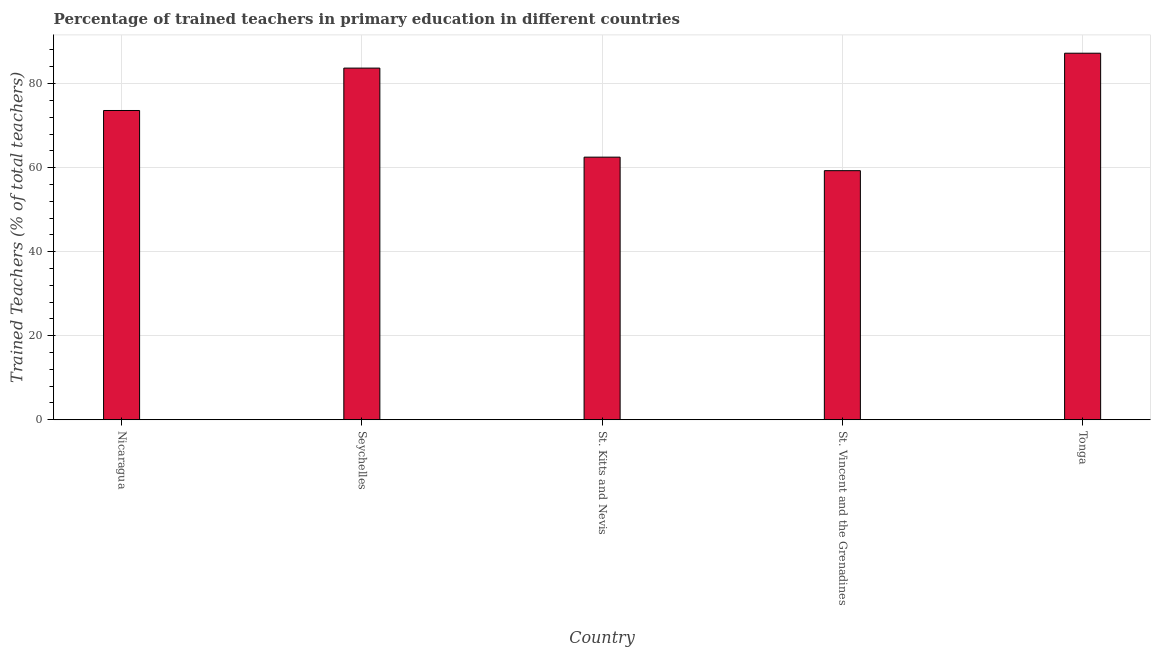What is the title of the graph?
Ensure brevity in your answer.  Percentage of trained teachers in primary education in different countries. What is the label or title of the X-axis?
Ensure brevity in your answer.  Country. What is the label or title of the Y-axis?
Keep it short and to the point. Trained Teachers (% of total teachers). What is the percentage of trained teachers in St. Kitts and Nevis?
Give a very brief answer. 62.5. Across all countries, what is the maximum percentage of trained teachers?
Offer a very short reply. 87.23. Across all countries, what is the minimum percentage of trained teachers?
Your answer should be very brief. 59.28. In which country was the percentage of trained teachers maximum?
Provide a short and direct response. Tonga. In which country was the percentage of trained teachers minimum?
Your answer should be compact. St. Vincent and the Grenadines. What is the sum of the percentage of trained teachers?
Your answer should be very brief. 366.31. What is the difference between the percentage of trained teachers in Seychelles and St. Kitts and Nevis?
Provide a succinct answer. 21.19. What is the average percentage of trained teachers per country?
Keep it short and to the point. 73.26. What is the median percentage of trained teachers?
Provide a succinct answer. 73.6. In how many countries, is the percentage of trained teachers greater than 72 %?
Give a very brief answer. 3. What is the ratio of the percentage of trained teachers in Seychelles to that in St. Kitts and Nevis?
Provide a short and direct response. 1.34. Is the percentage of trained teachers in Seychelles less than that in St. Vincent and the Grenadines?
Your response must be concise. No. Is the difference between the percentage of trained teachers in Nicaragua and St. Kitts and Nevis greater than the difference between any two countries?
Make the answer very short. No. What is the difference between the highest and the second highest percentage of trained teachers?
Your answer should be compact. 3.54. What is the difference between the highest and the lowest percentage of trained teachers?
Keep it short and to the point. 27.95. In how many countries, is the percentage of trained teachers greater than the average percentage of trained teachers taken over all countries?
Provide a short and direct response. 3. How many bars are there?
Make the answer very short. 5. How many countries are there in the graph?
Your response must be concise. 5. What is the Trained Teachers (% of total teachers) in Nicaragua?
Ensure brevity in your answer.  73.6. What is the Trained Teachers (% of total teachers) of Seychelles?
Provide a succinct answer. 83.69. What is the Trained Teachers (% of total teachers) of St. Kitts and Nevis?
Your answer should be compact. 62.5. What is the Trained Teachers (% of total teachers) of St. Vincent and the Grenadines?
Offer a very short reply. 59.28. What is the Trained Teachers (% of total teachers) of Tonga?
Give a very brief answer. 87.23. What is the difference between the Trained Teachers (% of total teachers) in Nicaragua and Seychelles?
Provide a succinct answer. -10.09. What is the difference between the Trained Teachers (% of total teachers) in Nicaragua and St. Kitts and Nevis?
Provide a succinct answer. 11.1. What is the difference between the Trained Teachers (% of total teachers) in Nicaragua and St. Vincent and the Grenadines?
Provide a short and direct response. 14.32. What is the difference between the Trained Teachers (% of total teachers) in Nicaragua and Tonga?
Provide a short and direct response. -13.63. What is the difference between the Trained Teachers (% of total teachers) in Seychelles and St. Kitts and Nevis?
Your answer should be very brief. 21.19. What is the difference between the Trained Teachers (% of total teachers) in Seychelles and St. Vincent and the Grenadines?
Offer a terse response. 24.4. What is the difference between the Trained Teachers (% of total teachers) in Seychelles and Tonga?
Your answer should be compact. -3.55. What is the difference between the Trained Teachers (% of total teachers) in St. Kitts and Nevis and St. Vincent and the Grenadines?
Provide a short and direct response. 3.21. What is the difference between the Trained Teachers (% of total teachers) in St. Kitts and Nevis and Tonga?
Provide a short and direct response. -24.73. What is the difference between the Trained Teachers (% of total teachers) in St. Vincent and the Grenadines and Tonga?
Your answer should be very brief. -27.95. What is the ratio of the Trained Teachers (% of total teachers) in Nicaragua to that in Seychelles?
Offer a very short reply. 0.88. What is the ratio of the Trained Teachers (% of total teachers) in Nicaragua to that in St. Kitts and Nevis?
Offer a very short reply. 1.18. What is the ratio of the Trained Teachers (% of total teachers) in Nicaragua to that in St. Vincent and the Grenadines?
Offer a terse response. 1.24. What is the ratio of the Trained Teachers (% of total teachers) in Nicaragua to that in Tonga?
Your response must be concise. 0.84. What is the ratio of the Trained Teachers (% of total teachers) in Seychelles to that in St. Kitts and Nevis?
Make the answer very short. 1.34. What is the ratio of the Trained Teachers (% of total teachers) in Seychelles to that in St. Vincent and the Grenadines?
Keep it short and to the point. 1.41. What is the ratio of the Trained Teachers (% of total teachers) in Seychelles to that in Tonga?
Your response must be concise. 0.96. What is the ratio of the Trained Teachers (% of total teachers) in St. Kitts and Nevis to that in St. Vincent and the Grenadines?
Your answer should be very brief. 1.05. What is the ratio of the Trained Teachers (% of total teachers) in St. Kitts and Nevis to that in Tonga?
Your answer should be very brief. 0.72. What is the ratio of the Trained Teachers (% of total teachers) in St. Vincent and the Grenadines to that in Tonga?
Keep it short and to the point. 0.68. 